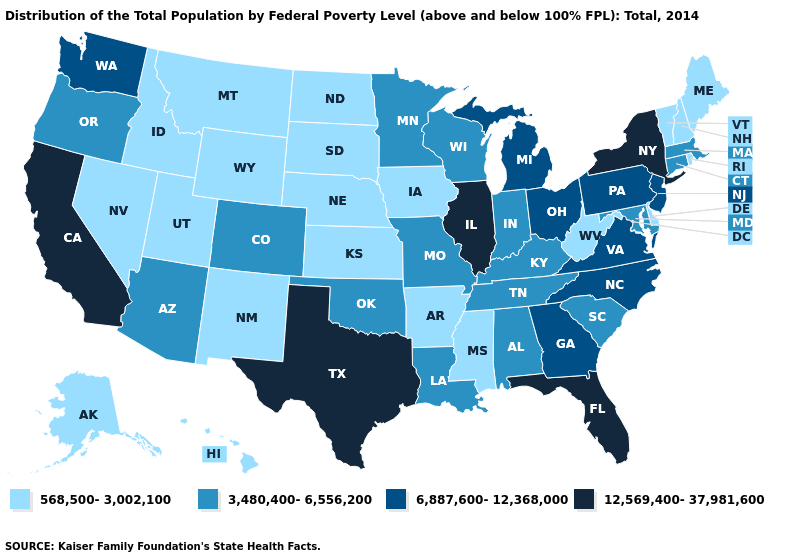What is the highest value in the USA?
Write a very short answer. 12,569,400-37,981,600. Name the states that have a value in the range 568,500-3,002,100?
Quick response, please. Alaska, Arkansas, Delaware, Hawaii, Idaho, Iowa, Kansas, Maine, Mississippi, Montana, Nebraska, Nevada, New Hampshire, New Mexico, North Dakota, Rhode Island, South Dakota, Utah, Vermont, West Virginia, Wyoming. Name the states that have a value in the range 6,887,600-12,368,000?
Be succinct. Georgia, Michigan, New Jersey, North Carolina, Ohio, Pennsylvania, Virginia, Washington. What is the highest value in the South ?
Give a very brief answer. 12,569,400-37,981,600. Name the states that have a value in the range 568,500-3,002,100?
Short answer required. Alaska, Arkansas, Delaware, Hawaii, Idaho, Iowa, Kansas, Maine, Mississippi, Montana, Nebraska, Nevada, New Hampshire, New Mexico, North Dakota, Rhode Island, South Dakota, Utah, Vermont, West Virginia, Wyoming. Does New Mexico have the lowest value in the West?
Keep it brief. Yes. Does Delaware have the highest value in the USA?
Write a very short answer. No. Name the states that have a value in the range 3,480,400-6,556,200?
Short answer required. Alabama, Arizona, Colorado, Connecticut, Indiana, Kentucky, Louisiana, Maryland, Massachusetts, Minnesota, Missouri, Oklahoma, Oregon, South Carolina, Tennessee, Wisconsin. Which states have the highest value in the USA?
Short answer required. California, Florida, Illinois, New York, Texas. Name the states that have a value in the range 3,480,400-6,556,200?
Concise answer only. Alabama, Arizona, Colorado, Connecticut, Indiana, Kentucky, Louisiana, Maryland, Massachusetts, Minnesota, Missouri, Oklahoma, Oregon, South Carolina, Tennessee, Wisconsin. Name the states that have a value in the range 6,887,600-12,368,000?
Keep it brief. Georgia, Michigan, New Jersey, North Carolina, Ohio, Pennsylvania, Virginia, Washington. What is the value of Alaska?
Short answer required. 568,500-3,002,100. Which states have the lowest value in the USA?
Short answer required. Alaska, Arkansas, Delaware, Hawaii, Idaho, Iowa, Kansas, Maine, Mississippi, Montana, Nebraska, Nevada, New Hampshire, New Mexico, North Dakota, Rhode Island, South Dakota, Utah, Vermont, West Virginia, Wyoming. What is the highest value in the USA?
Give a very brief answer. 12,569,400-37,981,600. 